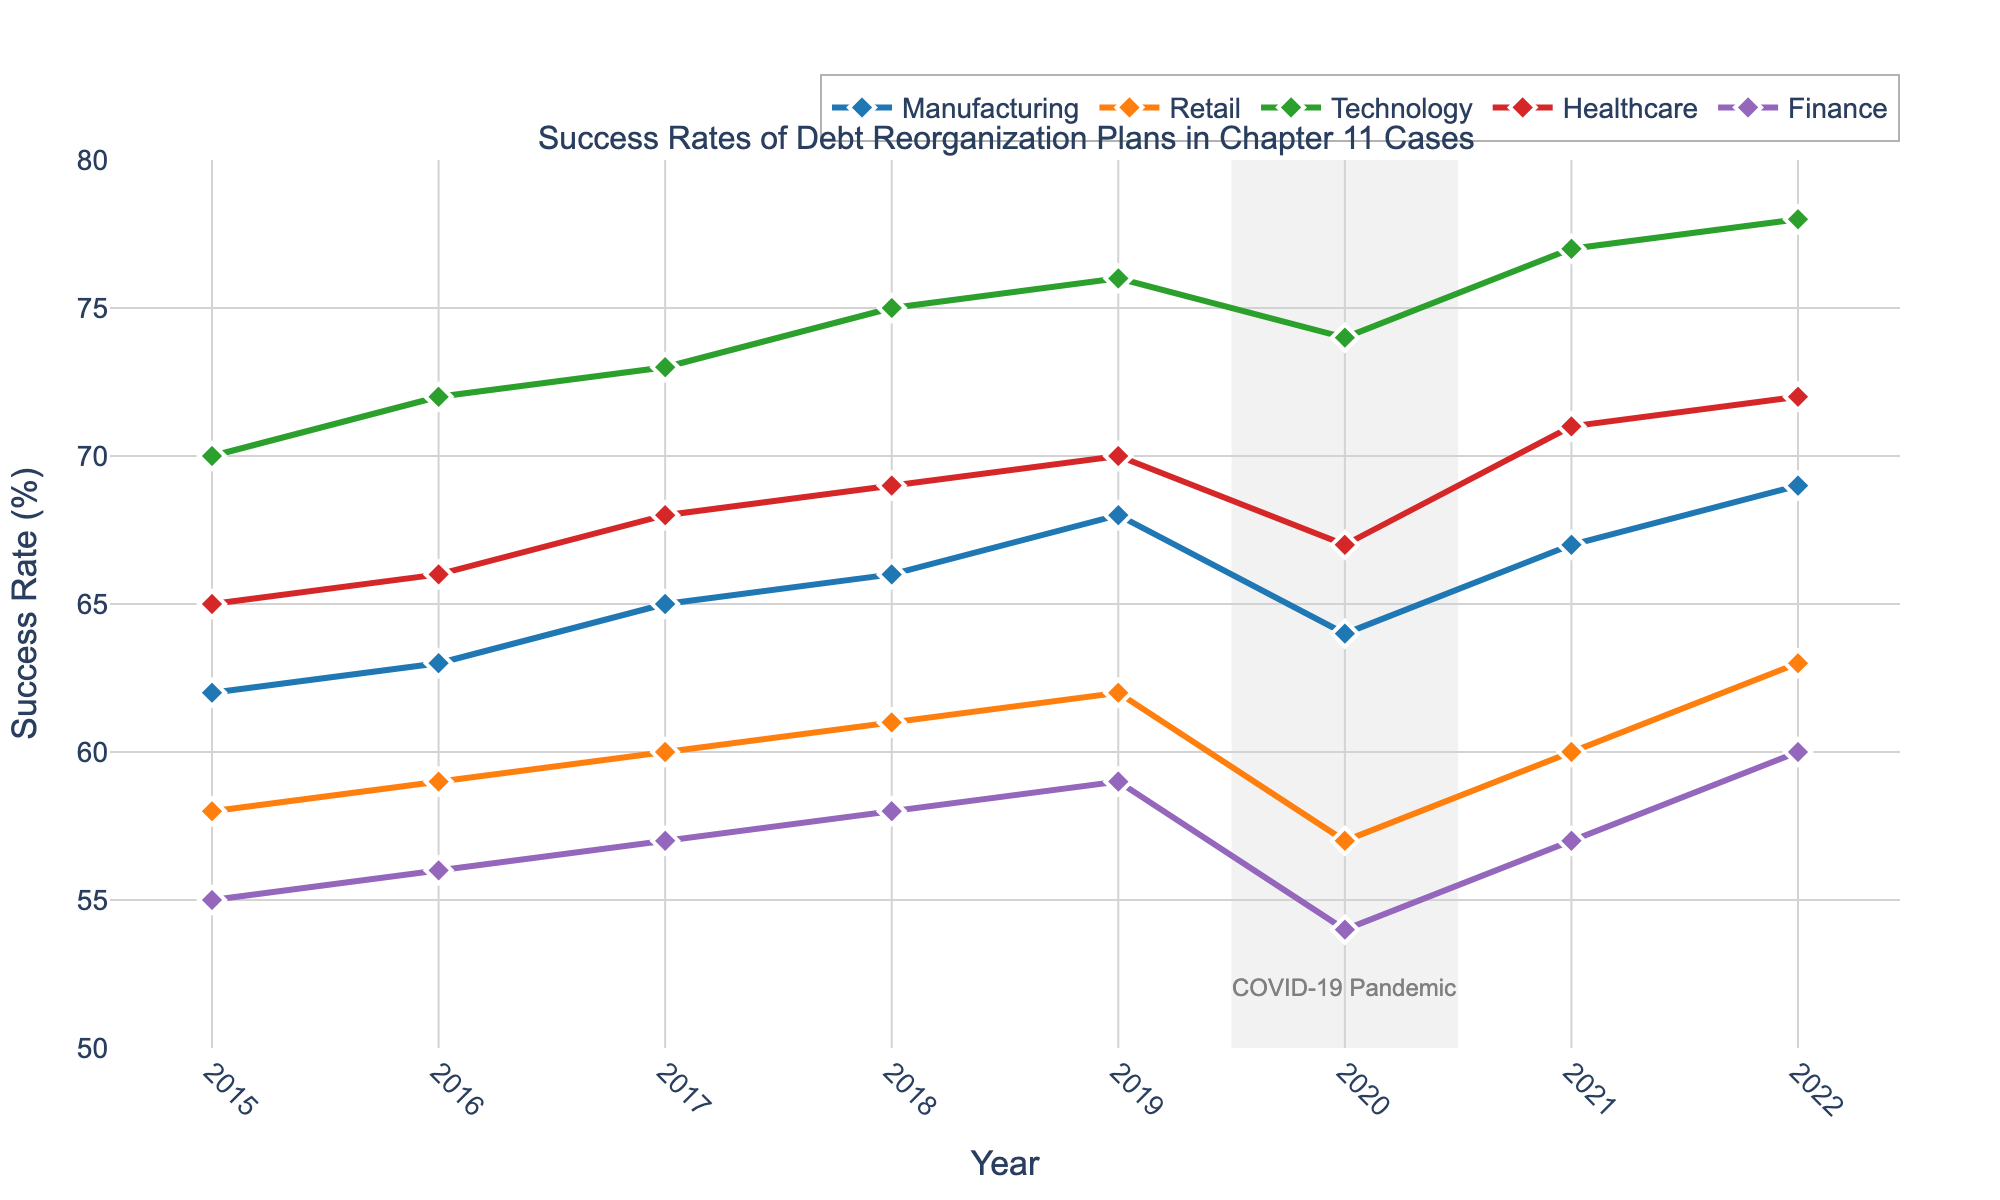What was the success rate for the Retail sector in 2020? The line chart shows the success rates of debt reorganization plans for different sectors by year. Looking specifically at Retail in 2020 from the chart, it is approximately 57%.
Answer: 57% Which sector had the highest success rate in 2021? To find this, compare all the sectors' success rates in 2021. The Technology sector had the highest success rate at approximately 77%.
Answer: Technology What is the difference between the success rates of Manufacturing and Finance sectors in 2022? First locate the success rates for Manufacturing and Finance in 2022 from the chart, which are 69% and 60% respectively. The difference is calculated as 69 - 60 = 9%.
Answer: 9% How did the success rate of the Healthcare sector change from 2019 to 2020? Observe the success rate of the Healthcare sector in 2019, which is approximately 70%, and in 2020, which is approximately 67%. The change is calculated as 67 - 70 = -3%.
Answer: -3% What trend do you observe in the success rates of the Technology sector from 2017 to 2022? From the chart, observe the Technology sector's trend line from 2017 to 2022. The success rate increases from approximately 73% in 2017 to 78% in 2022, indicating a consistently upward trend.
Answer: Upward trend What was the overall pattern for the Finance sector from 2015 to 2022? Analyzing the trend line for the Finance sector shows fluctuations: it starts at 55% in 2015, rises slightly till 2019 (59%), drops in 2020 (54%), and then increases again reaching 60% in 2022.
Answer: Fluctuating Which sector had the largest drop in success rate during the pandemic year 2020? To identify this, compare the success rates from 2019 to 2020 for each sector. The Retail sector dropped from 62% to 57%, showing the largest decrease.
Answer: Retail 